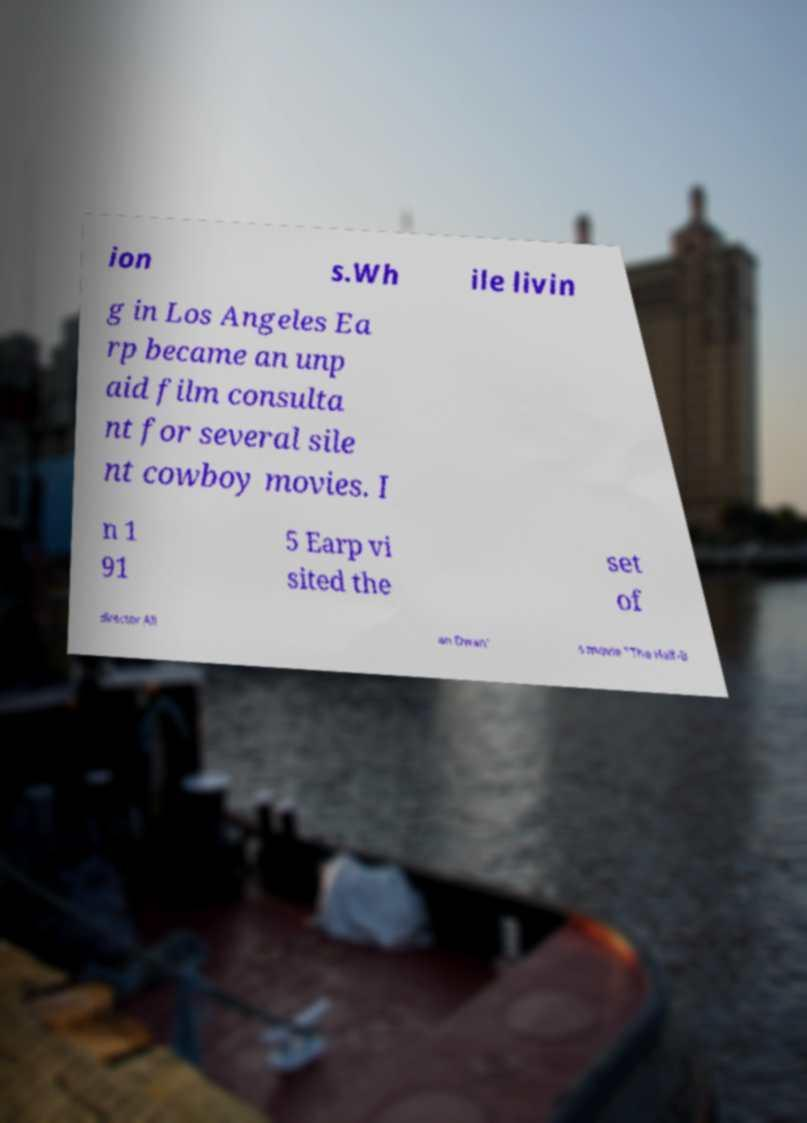Could you assist in decoding the text presented in this image and type it out clearly? ion s.Wh ile livin g in Los Angeles Ea rp became an unp aid film consulta nt for several sile nt cowboy movies. I n 1 91 5 Earp vi sited the set of director All an Dwan' s movie "The Half-B 